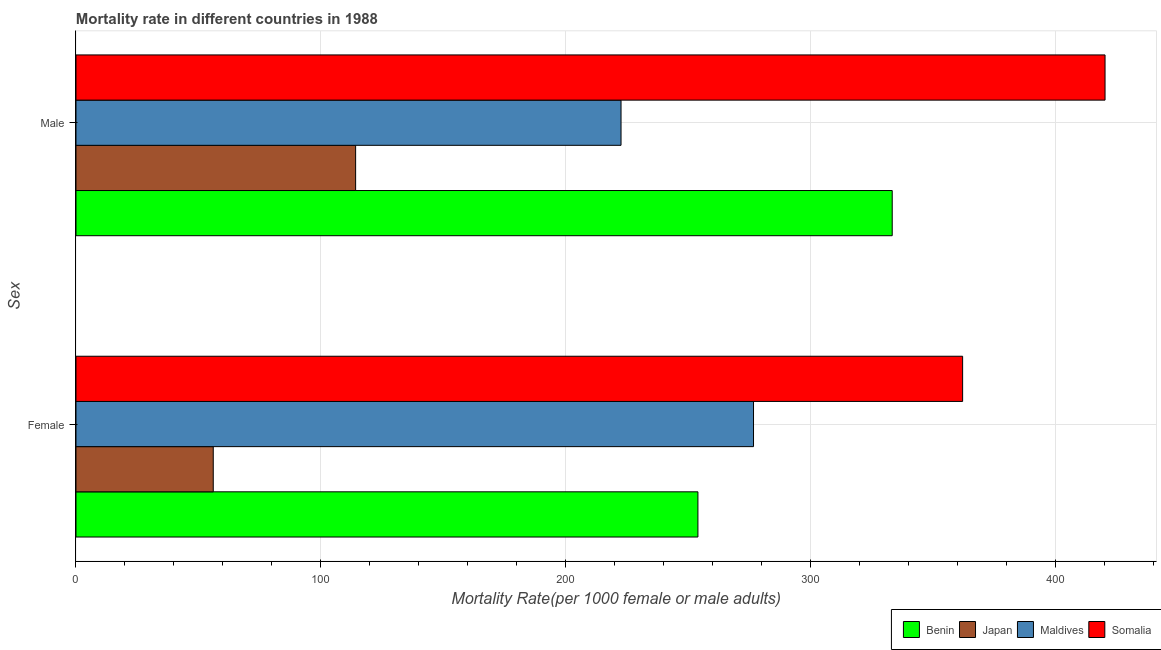Are the number of bars per tick equal to the number of legend labels?
Make the answer very short. Yes. What is the label of the 2nd group of bars from the top?
Make the answer very short. Female. What is the male mortality rate in Somalia?
Offer a terse response. 420.13. Across all countries, what is the maximum male mortality rate?
Your response must be concise. 420.13. Across all countries, what is the minimum male mortality rate?
Provide a short and direct response. 114.17. In which country was the male mortality rate maximum?
Your response must be concise. Somalia. In which country was the male mortality rate minimum?
Ensure brevity in your answer.  Japan. What is the total male mortality rate in the graph?
Offer a terse response. 1090.06. What is the difference between the female mortality rate in Somalia and that in Maldives?
Provide a succinct answer. 85.38. What is the difference between the male mortality rate in Somalia and the female mortality rate in Benin?
Provide a short and direct response. 166.21. What is the average female mortality rate per country?
Ensure brevity in your answer.  237.14. What is the difference between the female mortality rate and male mortality rate in Somalia?
Make the answer very short. -58.14. In how many countries, is the female mortality rate greater than 120 ?
Give a very brief answer. 3. What is the ratio of the female mortality rate in Somalia to that in Maldives?
Ensure brevity in your answer.  1.31. In how many countries, is the female mortality rate greater than the average female mortality rate taken over all countries?
Provide a short and direct response. 3. What does the 4th bar from the top in Male represents?
Provide a succinct answer. Benin. Are all the bars in the graph horizontal?
Your answer should be compact. Yes. What is the difference between two consecutive major ticks on the X-axis?
Provide a succinct answer. 100. Does the graph contain any zero values?
Offer a very short reply. No. Where does the legend appear in the graph?
Give a very brief answer. Bottom right. How many legend labels are there?
Your answer should be compact. 4. What is the title of the graph?
Your answer should be very brief. Mortality rate in different countries in 1988. What is the label or title of the X-axis?
Your response must be concise. Mortality Rate(per 1000 female or male adults). What is the label or title of the Y-axis?
Ensure brevity in your answer.  Sex. What is the Mortality Rate(per 1000 female or male adults) of Benin in Female?
Keep it short and to the point. 253.92. What is the Mortality Rate(per 1000 female or male adults) in Japan in Female?
Your answer should be very brief. 56.04. What is the Mortality Rate(per 1000 female or male adults) of Maldives in Female?
Offer a very short reply. 276.61. What is the Mortality Rate(per 1000 female or male adults) in Somalia in Female?
Provide a short and direct response. 361.99. What is the Mortality Rate(per 1000 female or male adults) of Benin in Male?
Make the answer very short. 333.24. What is the Mortality Rate(per 1000 female or male adults) in Japan in Male?
Provide a succinct answer. 114.17. What is the Mortality Rate(per 1000 female or male adults) in Maldives in Male?
Your answer should be compact. 222.52. What is the Mortality Rate(per 1000 female or male adults) of Somalia in Male?
Provide a short and direct response. 420.13. Across all Sex, what is the maximum Mortality Rate(per 1000 female or male adults) in Benin?
Give a very brief answer. 333.24. Across all Sex, what is the maximum Mortality Rate(per 1000 female or male adults) in Japan?
Provide a succinct answer. 114.17. Across all Sex, what is the maximum Mortality Rate(per 1000 female or male adults) in Maldives?
Offer a terse response. 276.61. Across all Sex, what is the maximum Mortality Rate(per 1000 female or male adults) of Somalia?
Ensure brevity in your answer.  420.13. Across all Sex, what is the minimum Mortality Rate(per 1000 female or male adults) of Benin?
Your answer should be compact. 253.92. Across all Sex, what is the minimum Mortality Rate(per 1000 female or male adults) of Japan?
Your response must be concise. 56.04. Across all Sex, what is the minimum Mortality Rate(per 1000 female or male adults) of Maldives?
Ensure brevity in your answer.  222.52. Across all Sex, what is the minimum Mortality Rate(per 1000 female or male adults) in Somalia?
Keep it short and to the point. 361.99. What is the total Mortality Rate(per 1000 female or male adults) in Benin in the graph?
Provide a short and direct response. 587.16. What is the total Mortality Rate(per 1000 female or male adults) in Japan in the graph?
Your answer should be compact. 170.2. What is the total Mortality Rate(per 1000 female or male adults) in Maldives in the graph?
Keep it short and to the point. 499.14. What is the total Mortality Rate(per 1000 female or male adults) of Somalia in the graph?
Your response must be concise. 782.12. What is the difference between the Mortality Rate(per 1000 female or male adults) of Benin in Female and that in Male?
Provide a short and direct response. -79.33. What is the difference between the Mortality Rate(per 1000 female or male adults) of Japan in Female and that in Male?
Provide a short and direct response. -58.13. What is the difference between the Mortality Rate(per 1000 female or male adults) in Maldives in Female and that in Male?
Provide a succinct answer. 54.09. What is the difference between the Mortality Rate(per 1000 female or male adults) of Somalia in Female and that in Male?
Give a very brief answer. -58.14. What is the difference between the Mortality Rate(per 1000 female or male adults) in Benin in Female and the Mortality Rate(per 1000 female or male adults) in Japan in Male?
Provide a succinct answer. 139.75. What is the difference between the Mortality Rate(per 1000 female or male adults) in Benin in Female and the Mortality Rate(per 1000 female or male adults) in Maldives in Male?
Your answer should be compact. 31.39. What is the difference between the Mortality Rate(per 1000 female or male adults) in Benin in Female and the Mortality Rate(per 1000 female or male adults) in Somalia in Male?
Ensure brevity in your answer.  -166.21. What is the difference between the Mortality Rate(per 1000 female or male adults) in Japan in Female and the Mortality Rate(per 1000 female or male adults) in Maldives in Male?
Offer a very short reply. -166.49. What is the difference between the Mortality Rate(per 1000 female or male adults) of Japan in Female and the Mortality Rate(per 1000 female or male adults) of Somalia in Male?
Make the answer very short. -364.09. What is the difference between the Mortality Rate(per 1000 female or male adults) in Maldives in Female and the Mortality Rate(per 1000 female or male adults) in Somalia in Male?
Offer a very short reply. -143.52. What is the average Mortality Rate(per 1000 female or male adults) of Benin per Sex?
Provide a succinct answer. 293.58. What is the average Mortality Rate(per 1000 female or male adults) in Japan per Sex?
Keep it short and to the point. 85.1. What is the average Mortality Rate(per 1000 female or male adults) in Maldives per Sex?
Offer a very short reply. 249.57. What is the average Mortality Rate(per 1000 female or male adults) of Somalia per Sex?
Your answer should be compact. 391.06. What is the difference between the Mortality Rate(per 1000 female or male adults) of Benin and Mortality Rate(per 1000 female or male adults) of Japan in Female?
Keep it short and to the point. 197.88. What is the difference between the Mortality Rate(per 1000 female or male adults) of Benin and Mortality Rate(per 1000 female or male adults) of Maldives in Female?
Ensure brevity in your answer.  -22.7. What is the difference between the Mortality Rate(per 1000 female or male adults) of Benin and Mortality Rate(per 1000 female or male adults) of Somalia in Female?
Offer a very short reply. -108.07. What is the difference between the Mortality Rate(per 1000 female or male adults) of Japan and Mortality Rate(per 1000 female or male adults) of Maldives in Female?
Offer a terse response. -220.57. What is the difference between the Mortality Rate(per 1000 female or male adults) of Japan and Mortality Rate(per 1000 female or male adults) of Somalia in Female?
Give a very brief answer. -305.95. What is the difference between the Mortality Rate(per 1000 female or male adults) of Maldives and Mortality Rate(per 1000 female or male adults) of Somalia in Female?
Provide a succinct answer. -85.38. What is the difference between the Mortality Rate(per 1000 female or male adults) in Benin and Mortality Rate(per 1000 female or male adults) in Japan in Male?
Your response must be concise. 219.08. What is the difference between the Mortality Rate(per 1000 female or male adults) in Benin and Mortality Rate(per 1000 female or male adults) in Maldives in Male?
Keep it short and to the point. 110.72. What is the difference between the Mortality Rate(per 1000 female or male adults) of Benin and Mortality Rate(per 1000 female or male adults) of Somalia in Male?
Provide a succinct answer. -86.89. What is the difference between the Mortality Rate(per 1000 female or male adults) in Japan and Mortality Rate(per 1000 female or male adults) in Maldives in Male?
Ensure brevity in your answer.  -108.36. What is the difference between the Mortality Rate(per 1000 female or male adults) in Japan and Mortality Rate(per 1000 female or male adults) in Somalia in Male?
Offer a very short reply. -305.97. What is the difference between the Mortality Rate(per 1000 female or male adults) in Maldives and Mortality Rate(per 1000 female or male adults) in Somalia in Male?
Give a very brief answer. -197.61. What is the ratio of the Mortality Rate(per 1000 female or male adults) of Benin in Female to that in Male?
Your answer should be very brief. 0.76. What is the ratio of the Mortality Rate(per 1000 female or male adults) in Japan in Female to that in Male?
Keep it short and to the point. 0.49. What is the ratio of the Mortality Rate(per 1000 female or male adults) of Maldives in Female to that in Male?
Offer a terse response. 1.24. What is the ratio of the Mortality Rate(per 1000 female or male adults) in Somalia in Female to that in Male?
Your answer should be very brief. 0.86. What is the difference between the highest and the second highest Mortality Rate(per 1000 female or male adults) of Benin?
Make the answer very short. 79.33. What is the difference between the highest and the second highest Mortality Rate(per 1000 female or male adults) of Japan?
Keep it short and to the point. 58.13. What is the difference between the highest and the second highest Mortality Rate(per 1000 female or male adults) of Maldives?
Keep it short and to the point. 54.09. What is the difference between the highest and the second highest Mortality Rate(per 1000 female or male adults) of Somalia?
Provide a short and direct response. 58.14. What is the difference between the highest and the lowest Mortality Rate(per 1000 female or male adults) of Benin?
Provide a short and direct response. 79.33. What is the difference between the highest and the lowest Mortality Rate(per 1000 female or male adults) of Japan?
Provide a short and direct response. 58.13. What is the difference between the highest and the lowest Mortality Rate(per 1000 female or male adults) in Maldives?
Ensure brevity in your answer.  54.09. What is the difference between the highest and the lowest Mortality Rate(per 1000 female or male adults) of Somalia?
Ensure brevity in your answer.  58.14. 